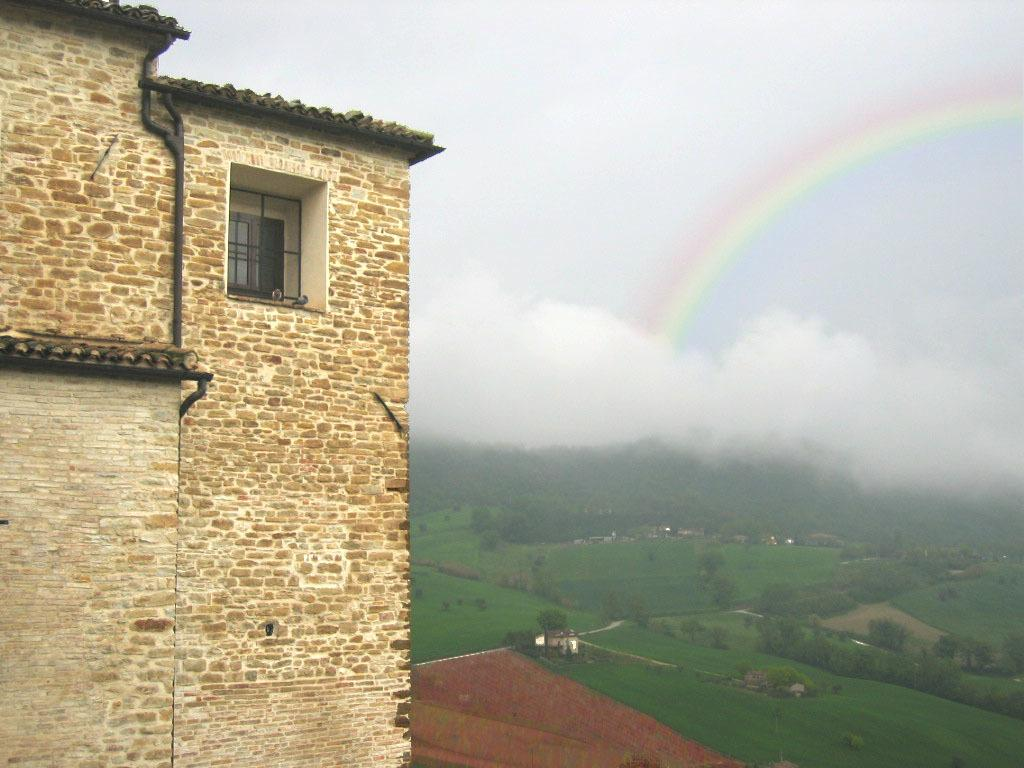What type of structure is on the left side of the image? There is a building with bricks on the left side of the image. What type of vegetation can be seen in the image? There is grass and trees in the image. What can be seen in the sky in the image? There is a rainbow and clouds visible in the sky. What type of bean is growing on the building in the image? There are no beans present in the image, and the building is made of bricks, not a plant. Can you see any bears in the image? There are no bears present in the image; the focus is on the building, vegetation, and sky. 